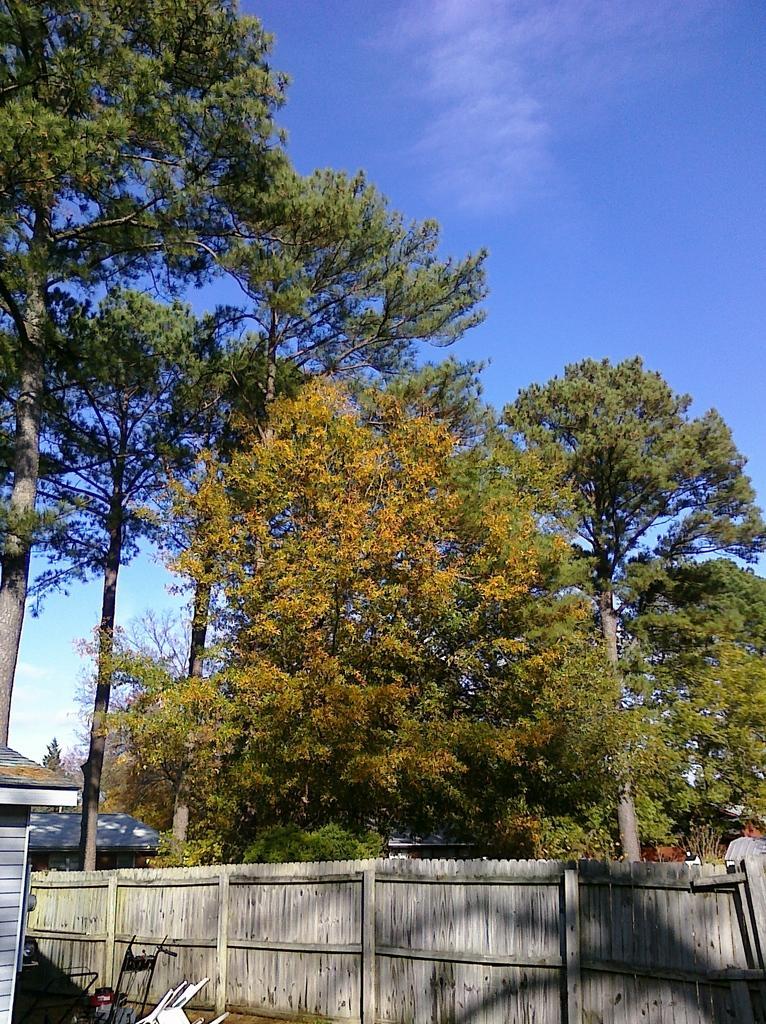How would you summarize this image in a sentence or two? This picture is clicked outside. In the foreground we can see there are some objects seems to be lying on the ground and we can see the wooden planks, houses, trees, sky and some other objects. 